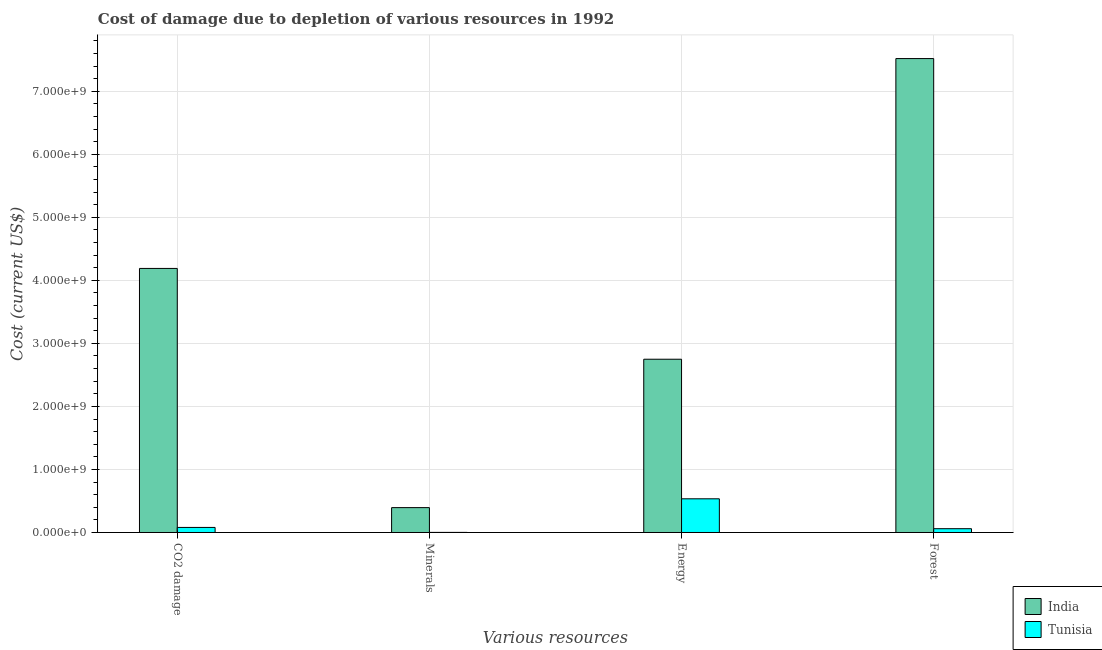How many groups of bars are there?
Ensure brevity in your answer.  4. Are the number of bars per tick equal to the number of legend labels?
Give a very brief answer. Yes. Are the number of bars on each tick of the X-axis equal?
Your answer should be compact. Yes. How many bars are there on the 3rd tick from the left?
Provide a succinct answer. 2. What is the label of the 1st group of bars from the left?
Provide a short and direct response. CO2 damage. What is the cost of damage due to depletion of minerals in India?
Provide a short and direct response. 3.94e+08. Across all countries, what is the maximum cost of damage due to depletion of coal?
Ensure brevity in your answer.  4.19e+09. Across all countries, what is the minimum cost of damage due to depletion of forests?
Keep it short and to the point. 6.02e+07. In which country was the cost of damage due to depletion of coal minimum?
Offer a very short reply. Tunisia. What is the total cost of damage due to depletion of forests in the graph?
Provide a succinct answer. 7.58e+09. What is the difference between the cost of damage due to depletion of coal in Tunisia and that in India?
Ensure brevity in your answer.  -4.11e+09. What is the difference between the cost of damage due to depletion of forests in Tunisia and the cost of damage due to depletion of energy in India?
Ensure brevity in your answer.  -2.69e+09. What is the average cost of damage due to depletion of coal per country?
Provide a short and direct response. 2.13e+09. What is the difference between the cost of damage due to depletion of minerals and cost of damage due to depletion of forests in Tunisia?
Your response must be concise. -5.87e+07. In how many countries, is the cost of damage due to depletion of energy greater than 4400000000 US$?
Offer a terse response. 0. What is the ratio of the cost of damage due to depletion of energy in Tunisia to that in India?
Offer a terse response. 0.19. Is the difference between the cost of damage due to depletion of forests in India and Tunisia greater than the difference between the cost of damage due to depletion of coal in India and Tunisia?
Your answer should be compact. Yes. What is the difference between the highest and the second highest cost of damage due to depletion of minerals?
Provide a succinct answer. 3.93e+08. What is the difference between the highest and the lowest cost of damage due to depletion of minerals?
Keep it short and to the point. 3.93e+08. In how many countries, is the cost of damage due to depletion of forests greater than the average cost of damage due to depletion of forests taken over all countries?
Offer a very short reply. 1. What does the 1st bar from the right in Minerals represents?
Your response must be concise. Tunisia. Is it the case that in every country, the sum of the cost of damage due to depletion of coal and cost of damage due to depletion of minerals is greater than the cost of damage due to depletion of energy?
Your answer should be very brief. No. What is the difference between two consecutive major ticks on the Y-axis?
Offer a very short reply. 1.00e+09. Are the values on the major ticks of Y-axis written in scientific E-notation?
Keep it short and to the point. Yes. Does the graph contain any zero values?
Your response must be concise. No. Does the graph contain grids?
Ensure brevity in your answer.  Yes. What is the title of the graph?
Keep it short and to the point. Cost of damage due to depletion of various resources in 1992 . Does "Mauritania" appear as one of the legend labels in the graph?
Keep it short and to the point. No. What is the label or title of the X-axis?
Give a very brief answer. Various resources. What is the label or title of the Y-axis?
Ensure brevity in your answer.  Cost (current US$). What is the Cost (current US$) in India in CO2 damage?
Ensure brevity in your answer.  4.19e+09. What is the Cost (current US$) of Tunisia in CO2 damage?
Provide a succinct answer. 8.03e+07. What is the Cost (current US$) in India in Minerals?
Keep it short and to the point. 3.94e+08. What is the Cost (current US$) in Tunisia in Minerals?
Ensure brevity in your answer.  1.50e+06. What is the Cost (current US$) of India in Energy?
Provide a succinct answer. 2.75e+09. What is the Cost (current US$) of Tunisia in Energy?
Offer a very short reply. 5.34e+08. What is the Cost (current US$) in India in Forest?
Give a very brief answer. 7.52e+09. What is the Cost (current US$) of Tunisia in Forest?
Your answer should be very brief. 6.02e+07. Across all Various resources, what is the maximum Cost (current US$) of India?
Offer a very short reply. 7.52e+09. Across all Various resources, what is the maximum Cost (current US$) of Tunisia?
Your response must be concise. 5.34e+08. Across all Various resources, what is the minimum Cost (current US$) in India?
Keep it short and to the point. 3.94e+08. Across all Various resources, what is the minimum Cost (current US$) of Tunisia?
Your response must be concise. 1.50e+06. What is the total Cost (current US$) in India in the graph?
Your answer should be very brief. 1.49e+1. What is the total Cost (current US$) of Tunisia in the graph?
Provide a short and direct response. 6.76e+08. What is the difference between the Cost (current US$) in India in CO2 damage and that in Minerals?
Make the answer very short. 3.79e+09. What is the difference between the Cost (current US$) in Tunisia in CO2 damage and that in Minerals?
Provide a short and direct response. 7.88e+07. What is the difference between the Cost (current US$) in India in CO2 damage and that in Energy?
Your answer should be very brief. 1.44e+09. What is the difference between the Cost (current US$) in Tunisia in CO2 damage and that in Energy?
Keep it short and to the point. -4.54e+08. What is the difference between the Cost (current US$) of India in CO2 damage and that in Forest?
Your response must be concise. -3.33e+09. What is the difference between the Cost (current US$) of Tunisia in CO2 damage and that in Forest?
Provide a short and direct response. 2.01e+07. What is the difference between the Cost (current US$) of India in Minerals and that in Energy?
Offer a very short reply. -2.35e+09. What is the difference between the Cost (current US$) of Tunisia in Minerals and that in Energy?
Offer a terse response. -5.33e+08. What is the difference between the Cost (current US$) of India in Minerals and that in Forest?
Provide a succinct answer. -7.12e+09. What is the difference between the Cost (current US$) of Tunisia in Minerals and that in Forest?
Ensure brevity in your answer.  -5.87e+07. What is the difference between the Cost (current US$) of India in Energy and that in Forest?
Make the answer very short. -4.77e+09. What is the difference between the Cost (current US$) of Tunisia in Energy and that in Forest?
Keep it short and to the point. 4.74e+08. What is the difference between the Cost (current US$) in India in CO2 damage and the Cost (current US$) in Tunisia in Minerals?
Offer a terse response. 4.19e+09. What is the difference between the Cost (current US$) of India in CO2 damage and the Cost (current US$) of Tunisia in Energy?
Give a very brief answer. 3.65e+09. What is the difference between the Cost (current US$) of India in CO2 damage and the Cost (current US$) of Tunisia in Forest?
Offer a very short reply. 4.13e+09. What is the difference between the Cost (current US$) in India in Minerals and the Cost (current US$) in Tunisia in Energy?
Your answer should be compact. -1.40e+08. What is the difference between the Cost (current US$) of India in Minerals and the Cost (current US$) of Tunisia in Forest?
Give a very brief answer. 3.34e+08. What is the difference between the Cost (current US$) in India in Energy and the Cost (current US$) in Tunisia in Forest?
Give a very brief answer. 2.69e+09. What is the average Cost (current US$) in India per Various resources?
Ensure brevity in your answer.  3.71e+09. What is the average Cost (current US$) in Tunisia per Various resources?
Provide a short and direct response. 1.69e+08. What is the difference between the Cost (current US$) in India and Cost (current US$) in Tunisia in CO2 damage?
Ensure brevity in your answer.  4.11e+09. What is the difference between the Cost (current US$) in India and Cost (current US$) in Tunisia in Minerals?
Your answer should be compact. 3.93e+08. What is the difference between the Cost (current US$) in India and Cost (current US$) in Tunisia in Energy?
Make the answer very short. 2.21e+09. What is the difference between the Cost (current US$) in India and Cost (current US$) in Tunisia in Forest?
Ensure brevity in your answer.  7.46e+09. What is the ratio of the Cost (current US$) of India in CO2 damage to that in Minerals?
Offer a terse response. 10.62. What is the ratio of the Cost (current US$) in Tunisia in CO2 damage to that in Minerals?
Provide a succinct answer. 53.64. What is the ratio of the Cost (current US$) of India in CO2 damage to that in Energy?
Give a very brief answer. 1.52. What is the ratio of the Cost (current US$) in Tunisia in CO2 damage to that in Energy?
Offer a very short reply. 0.15. What is the ratio of the Cost (current US$) in India in CO2 damage to that in Forest?
Make the answer very short. 0.56. What is the ratio of the Cost (current US$) of Tunisia in CO2 damage to that in Forest?
Give a very brief answer. 1.33. What is the ratio of the Cost (current US$) of India in Minerals to that in Energy?
Your response must be concise. 0.14. What is the ratio of the Cost (current US$) of Tunisia in Minerals to that in Energy?
Offer a very short reply. 0. What is the ratio of the Cost (current US$) in India in Minerals to that in Forest?
Your response must be concise. 0.05. What is the ratio of the Cost (current US$) of Tunisia in Minerals to that in Forest?
Offer a terse response. 0.02. What is the ratio of the Cost (current US$) of India in Energy to that in Forest?
Your answer should be very brief. 0.37. What is the ratio of the Cost (current US$) in Tunisia in Energy to that in Forest?
Offer a very short reply. 8.87. What is the difference between the highest and the second highest Cost (current US$) in India?
Your answer should be very brief. 3.33e+09. What is the difference between the highest and the second highest Cost (current US$) in Tunisia?
Offer a terse response. 4.54e+08. What is the difference between the highest and the lowest Cost (current US$) in India?
Offer a terse response. 7.12e+09. What is the difference between the highest and the lowest Cost (current US$) of Tunisia?
Your answer should be very brief. 5.33e+08. 